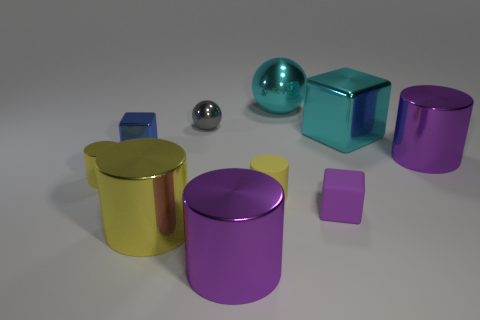What is the size of the metallic object that is the same color as the big block?
Make the answer very short. Large. There is a large ball that is the same color as the large cube; what is it made of?
Provide a succinct answer. Metal. Is there a yellow ball that has the same material as the blue thing?
Offer a very short reply. No. Is the tiny shiny cylinder the same color as the large metallic block?
Your answer should be very brief. No. What is the material of the cylinder that is both in front of the tiny yellow matte cylinder and right of the big yellow object?
Ensure brevity in your answer.  Metal. What is the color of the matte cylinder?
Provide a short and direct response. Yellow. How many purple metal objects have the same shape as the big yellow object?
Make the answer very short. 2. Do the big purple cylinder that is to the right of the large shiny block and the small yellow cylinder to the left of the tiny gray metallic ball have the same material?
Make the answer very short. Yes. How big is the purple metallic thing in front of the tiny matte thing that is to the left of the cyan metal sphere?
Your answer should be compact. Large. Is there any other thing that is the same size as the blue cube?
Your answer should be compact. Yes. 